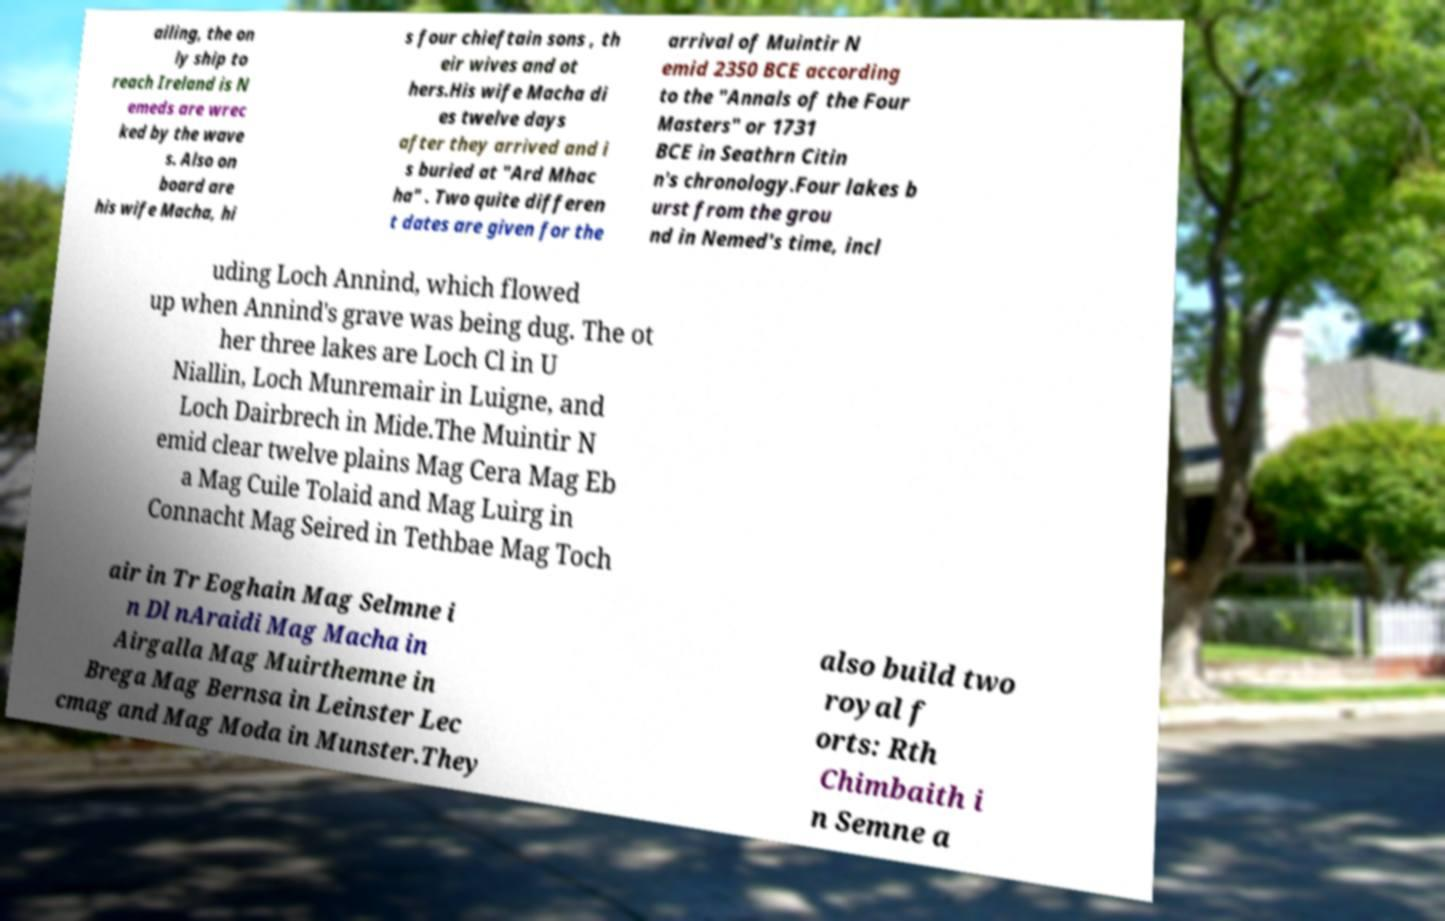Could you assist in decoding the text presented in this image and type it out clearly? ailing, the on ly ship to reach Ireland is N emeds are wrec ked by the wave s. Also on board are his wife Macha, hi s four chieftain sons , th eir wives and ot hers.His wife Macha di es twelve days after they arrived and i s buried at "Ard Mhac ha" . Two quite differen t dates are given for the arrival of Muintir N emid 2350 BCE according to the "Annals of the Four Masters" or 1731 BCE in Seathrn Citin n's chronology.Four lakes b urst from the grou nd in Nemed's time, incl uding Loch Annind, which flowed up when Annind's grave was being dug. The ot her three lakes are Loch Cl in U Niallin, Loch Munremair in Luigne, and Loch Dairbrech in Mide.The Muintir N emid clear twelve plains Mag Cera Mag Eb a Mag Cuile Tolaid and Mag Luirg in Connacht Mag Seired in Tethbae Mag Toch air in Tr Eoghain Mag Selmne i n Dl nAraidi Mag Macha in Airgalla Mag Muirthemne in Brega Mag Bernsa in Leinster Lec cmag and Mag Moda in Munster.They also build two royal f orts: Rth Chimbaith i n Semne a 